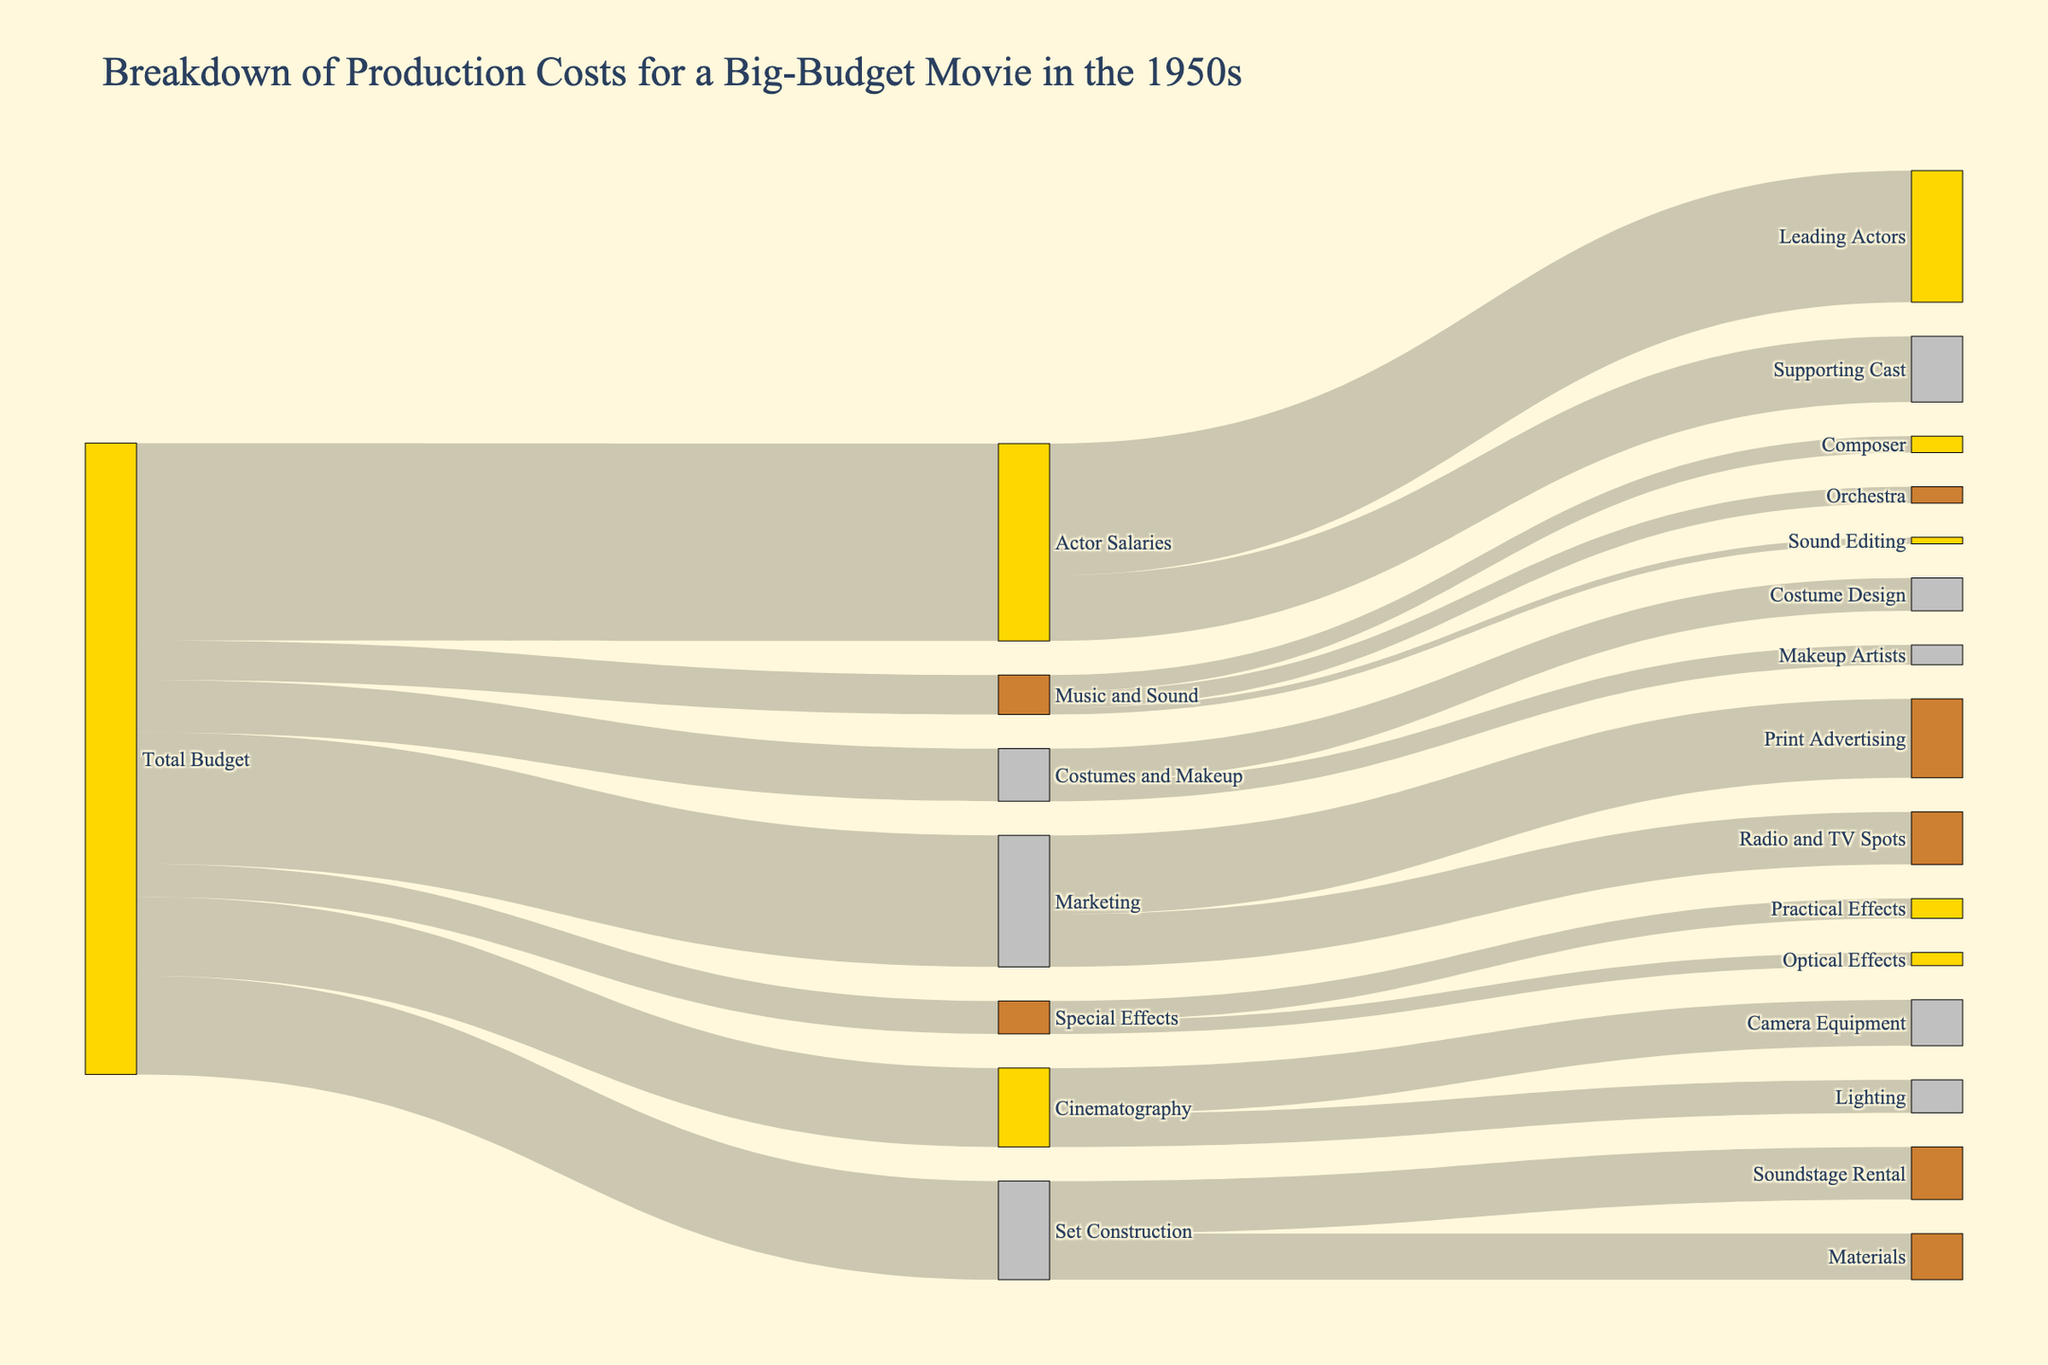What's the total budget for a typical big-budget movie in the 1950s? The total budget is represented as the source for all other expenditures. Adding up the values branching from "Total Budget" will give the total budget.
Answer: $9,600,000 How much was spent on actor salaries in total? Referring to the flow from "Total Budget" to "Actor Salaries," we see the value listed.
Answer: $3,000,000 Which category had the highest production cost? Directly comparing the values branching out from "Total Budget" will reveal that "Actor Salaries" is the highest.
Answer: Actor Salaries What is the combined cost of Set Construction and Cinematography? Summing the values from "Total Budget" to "Set Construction" and "Cinematography" gives us the combined cost: $1,500,000 + $1,200,000.
Answer: $2,700,000 What percentage of the total budget was spent on marketing? The marketing cost relative to the total budget can be calculated as ($2,000,000 / $9,600,000) * 100.
Answer: 20.8% How were the actor salaries divided among leading and supporting actors? The flow from "Actor Salaries" splits into "Leading Actors" and "Supporting Cast," showing values of $2,000,000 and $1,000,000, respectively.
Answer: Leading: $2,000,000, Supporting: $1,000,000 Which specific subcategory under Set Construction had a higher cost? Comparing "Soundstage Rental" and "Materials," with values $800,000 and $700,000 respectively, shows "Soundstage Rental" higher.
Answer: Soundstage Rental If $500,000 was spent on special effects, how much was allocated for practical effects? The flow from "Special Effects" splits into "Practical Effects" and "Optical Effects," with "Practical Effects" receiving $300,000.
Answer: $300,000 What is the total cost of Costumes and Makeup? The sum of "Costume Design" and "Makeup Artists" from "Costumes and Makeup" gives us $500,000 + $300,000.
Answer: $800,000 Compare the expenditure on music and sound editing to the budget for special effects. Which is higher? Comparing "Music and Sound" ($600,000) with "Special Effects" ($500,000), the former is higher.
Answer: Music and Sound 